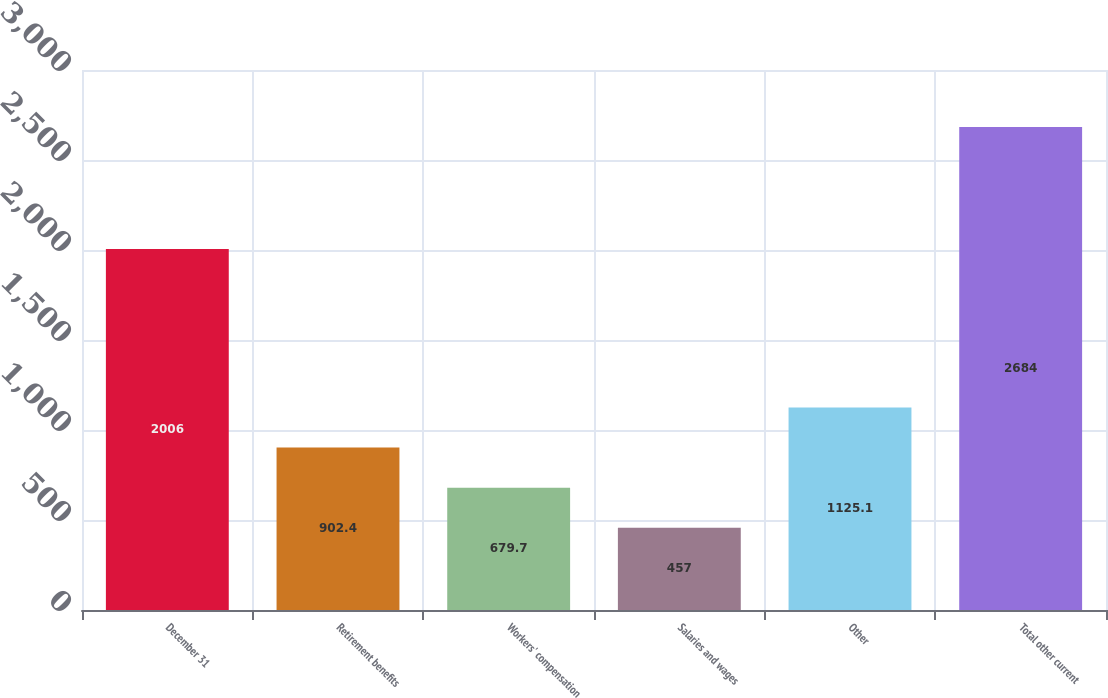<chart> <loc_0><loc_0><loc_500><loc_500><bar_chart><fcel>December 31<fcel>Retirement benefits<fcel>Workers' compensation<fcel>Salaries and wages<fcel>Other<fcel>Total other current<nl><fcel>2006<fcel>902.4<fcel>679.7<fcel>457<fcel>1125.1<fcel>2684<nl></chart> 